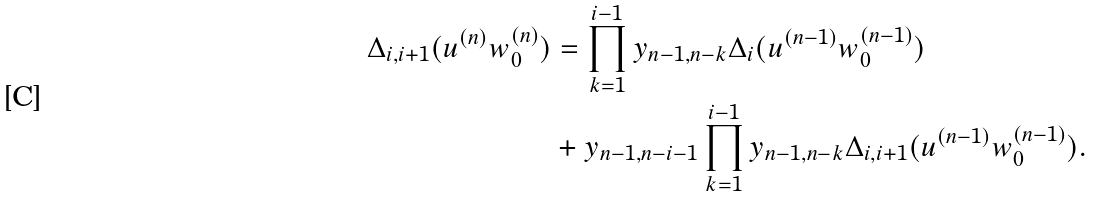<formula> <loc_0><loc_0><loc_500><loc_500>\Delta _ { i , i + 1 } ( u ^ { ( n ) } w _ { 0 } ^ { ( n ) } ) & = \prod _ { k = 1 } ^ { i - 1 } y _ { n - 1 , n - k } \Delta _ { i } ( u ^ { ( n - 1 ) } w _ { 0 } ^ { ( n - 1 ) } ) \\ & + y _ { n - 1 , n - i - 1 } \prod _ { k = 1 } ^ { i - 1 } y _ { n - 1 , n - k } \Delta _ { i , i + 1 } ( u ^ { ( n - 1 ) } w _ { 0 } ^ { ( n - 1 ) } ) .</formula> 